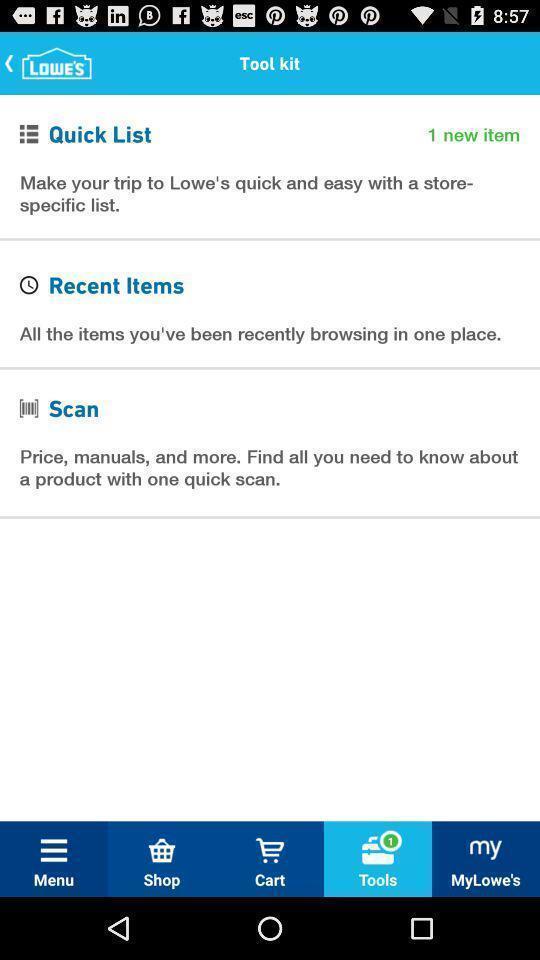Describe the key features of this screenshot. Screen displaying the list of options in tool page. 